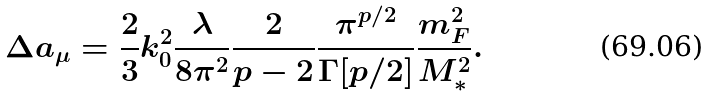<formula> <loc_0><loc_0><loc_500><loc_500>\Delta a _ { \mu } = \frac { 2 } { 3 } k _ { 0 } ^ { 2 } \frac { \lambda } { 8 \pi ^ { 2 } } \frac { 2 } { p - 2 } \frac { \pi ^ { p / 2 } } { \Gamma [ p / 2 ] } \frac { m _ { F } ^ { 2 } } { M _ { * } ^ { 2 } } .</formula> 